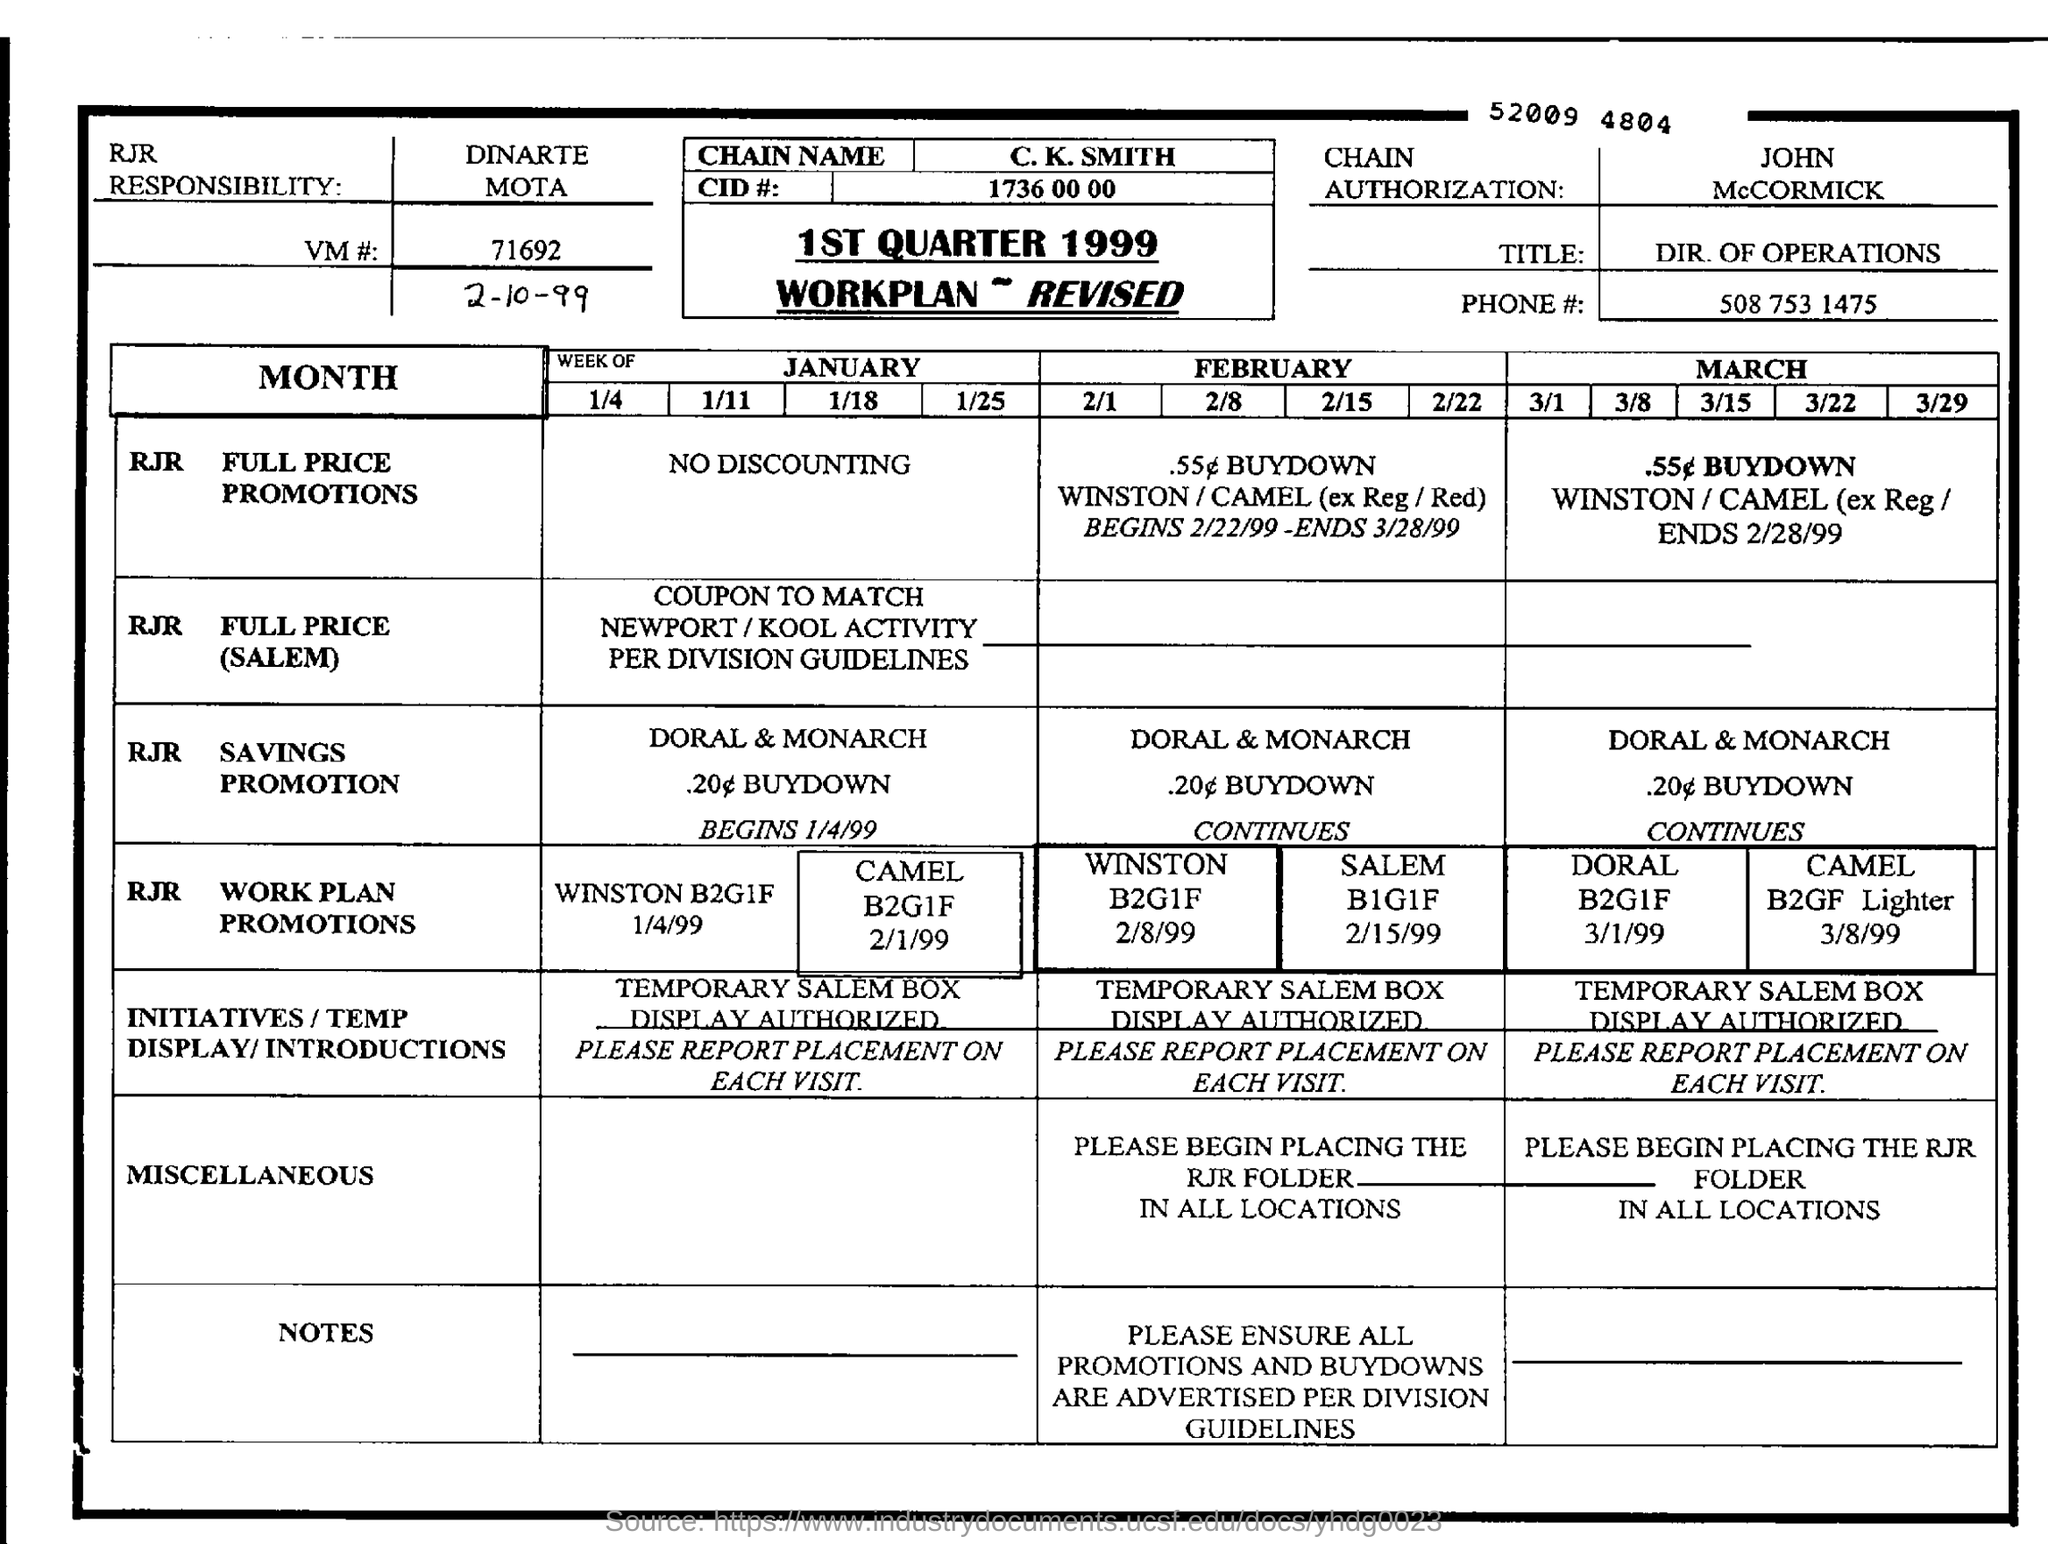What is the vm number
Keep it short and to the point. 71692. What is the value mentioned in the cid#:
Offer a very short reply. 1736 00 00. 